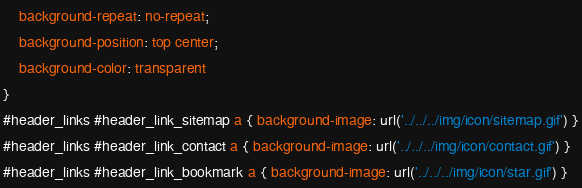Convert code to text. <code><loc_0><loc_0><loc_500><loc_500><_CSS_>	background-repeat: no-repeat;
	background-position: top center;
	background-color: transparent
}
#header_links #header_link_sitemap a { background-image: url('../../../img/icon/sitemap.gif') }
#header_links #header_link_contact a { background-image: url('../../../img/icon/contact.gif') }
#header_links #header_link_bookmark a { background-image: url('../../../img/icon/star.gif') }</code> 